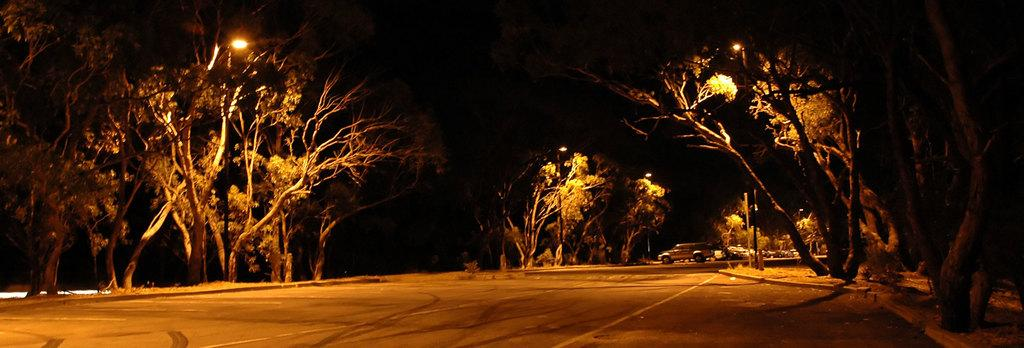What is the main feature of the image? There is a road in the image. What can be seen on both sides of the road? Trees are present on both sides of the road. What type of lighting is visible in the image? Street lights are visible in the image. What else can be seen in the background of the image? There are cars in the background of the image. What type of pie is being served on the can in the image? There is no pie or can present in the image; it features a road with trees, street lights, and cars in the background. 